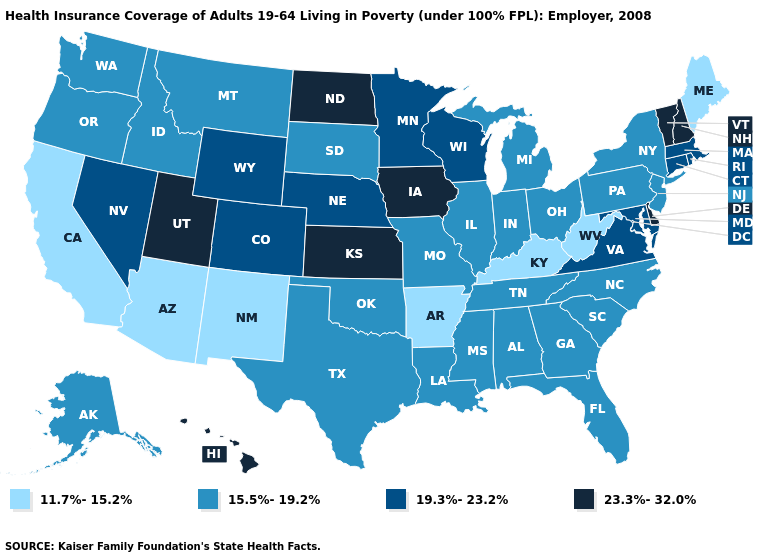How many symbols are there in the legend?
Give a very brief answer. 4. Which states hav the highest value in the South?
Quick response, please. Delaware. Name the states that have a value in the range 23.3%-32.0%?
Be succinct. Delaware, Hawaii, Iowa, Kansas, New Hampshire, North Dakota, Utah, Vermont. Does Georgia have a higher value than Maryland?
Quick response, please. No. What is the highest value in the USA?
Answer briefly. 23.3%-32.0%. Which states hav the highest value in the West?
Be succinct. Hawaii, Utah. Name the states that have a value in the range 11.7%-15.2%?
Answer briefly. Arizona, Arkansas, California, Kentucky, Maine, New Mexico, West Virginia. What is the highest value in states that border Indiana?
Concise answer only. 15.5%-19.2%. Which states have the lowest value in the USA?
Answer briefly. Arizona, Arkansas, California, Kentucky, Maine, New Mexico, West Virginia. Name the states that have a value in the range 11.7%-15.2%?
Be succinct. Arizona, Arkansas, California, Kentucky, Maine, New Mexico, West Virginia. What is the value of New Mexico?
Answer briefly. 11.7%-15.2%. What is the lowest value in the USA?
Short answer required. 11.7%-15.2%. Name the states that have a value in the range 23.3%-32.0%?
Short answer required. Delaware, Hawaii, Iowa, Kansas, New Hampshire, North Dakota, Utah, Vermont. Name the states that have a value in the range 15.5%-19.2%?
Concise answer only. Alabama, Alaska, Florida, Georgia, Idaho, Illinois, Indiana, Louisiana, Michigan, Mississippi, Missouri, Montana, New Jersey, New York, North Carolina, Ohio, Oklahoma, Oregon, Pennsylvania, South Carolina, South Dakota, Tennessee, Texas, Washington. Name the states that have a value in the range 11.7%-15.2%?
Short answer required. Arizona, Arkansas, California, Kentucky, Maine, New Mexico, West Virginia. 